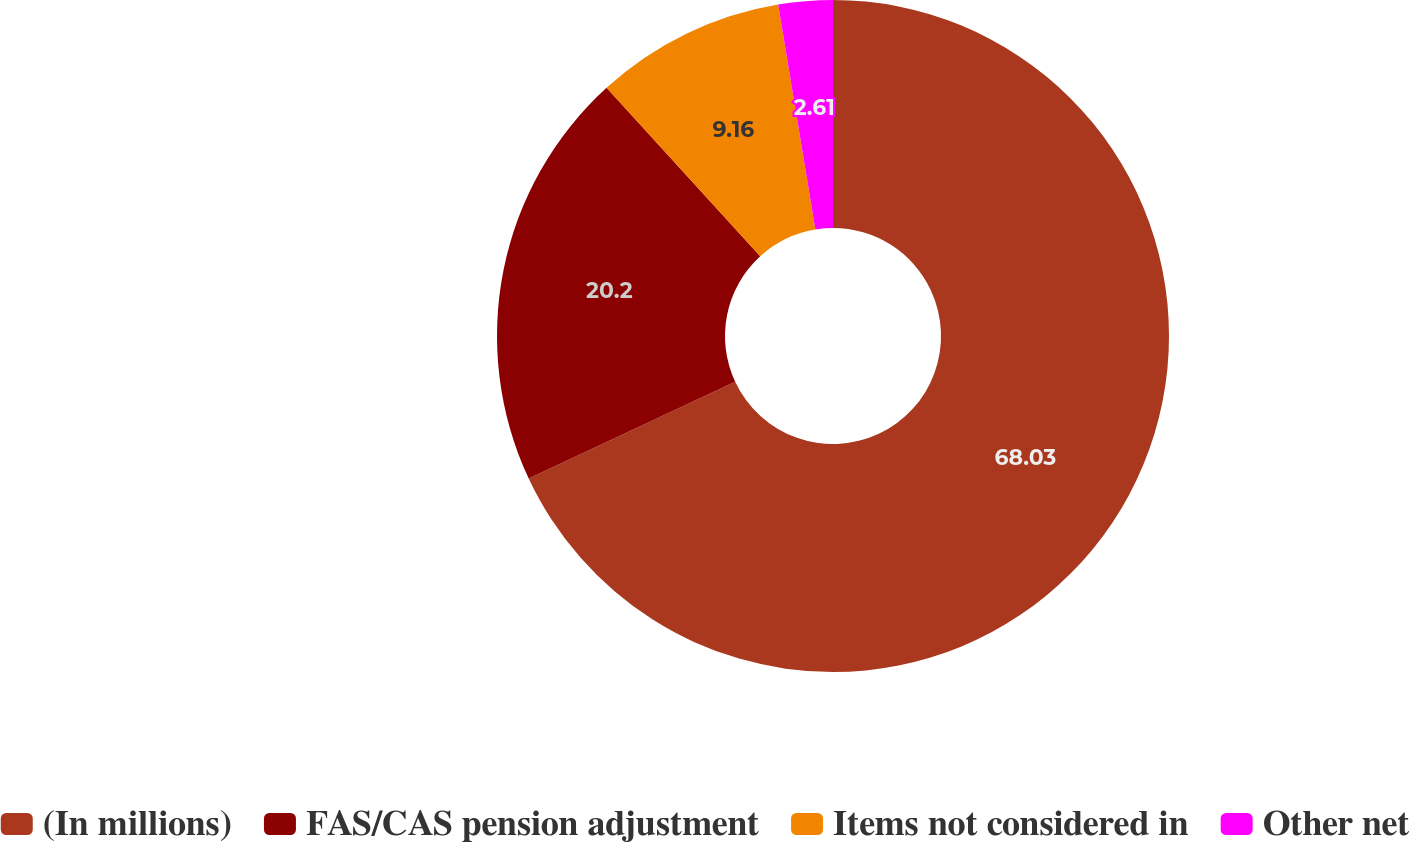Convert chart. <chart><loc_0><loc_0><loc_500><loc_500><pie_chart><fcel>(In millions)<fcel>FAS/CAS pension adjustment<fcel>Items not considered in<fcel>Other net<nl><fcel>68.03%<fcel>20.2%<fcel>9.16%<fcel>2.61%<nl></chart> 